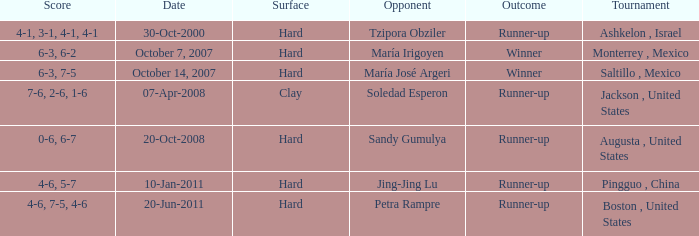Who was the opponent with a score of 4-6, 7-5, 4-6? Petra Rampre. 